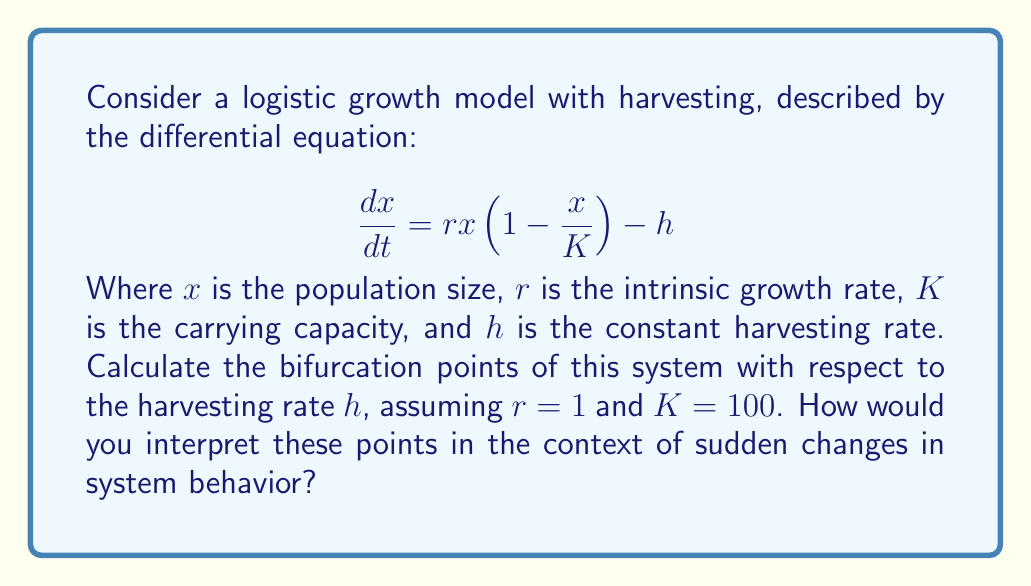Give your solution to this math problem. To find the bifurcation points, we need to follow these steps:

1) First, find the equilibrium points by setting $\frac{dx}{dt} = 0$:

   $$rx(1-\frac{x}{K}) - h = 0$$

2) Substitute the given values $r=1$ and $K=100$:

   $$x(1-\frac{x}{100}) - h =ustx^2 - x + h = 0$$

3) Solve this quadratic equation:

   $$x = \frac{100 \pm \sqrt{10000 - 40000h}}{200}$$

4) For real solutions to exist, the discriminant must be non-negative:

   $$10000 - 40000h \geq 0$$
   $$h \leq \frac{1}{4} = 0.25$$

5) The bifurcation occurs when the two equilibrium points coincide, which happens when the discriminant is zero:

   $$10000 - 40000h = 0$$
   $$h = \frac{1}{4} = 0.25$$

6) Therefore, the bifurcation point occurs at $h = 0.25$.

Interpretation: At $h = 0.25$, the system undergoes a sudden change in behavior. For $h < 0.25$, there are two equilibrium points (one stable, one unstable). For $h > 0.25$, there are no real equilibrium points, indicating population collapse. The bifurcation point represents the maximum sustainable harvest rate.
Answer: $h = 0.25$ 